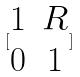<formula> <loc_0><loc_0><loc_500><loc_500>[ \begin{matrix} 1 & R \\ 0 & 1 \end{matrix} ]</formula> 